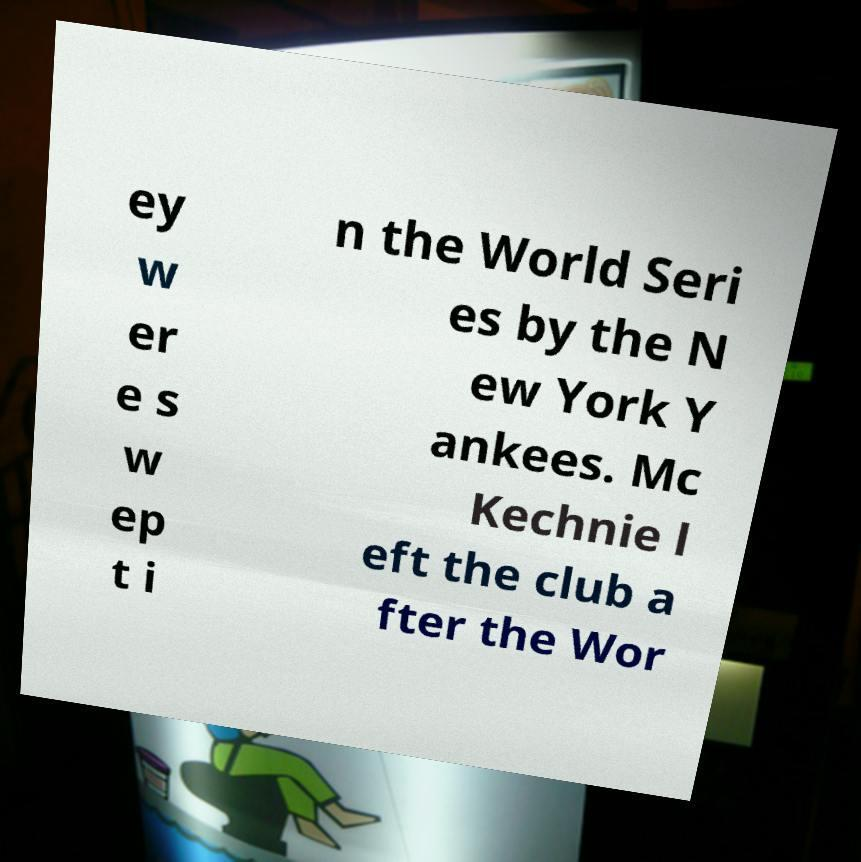What messages or text are displayed in this image? I need them in a readable, typed format. ey w er e s w ep t i n the World Seri es by the N ew York Y ankees. Mc Kechnie l eft the club a fter the Wor 